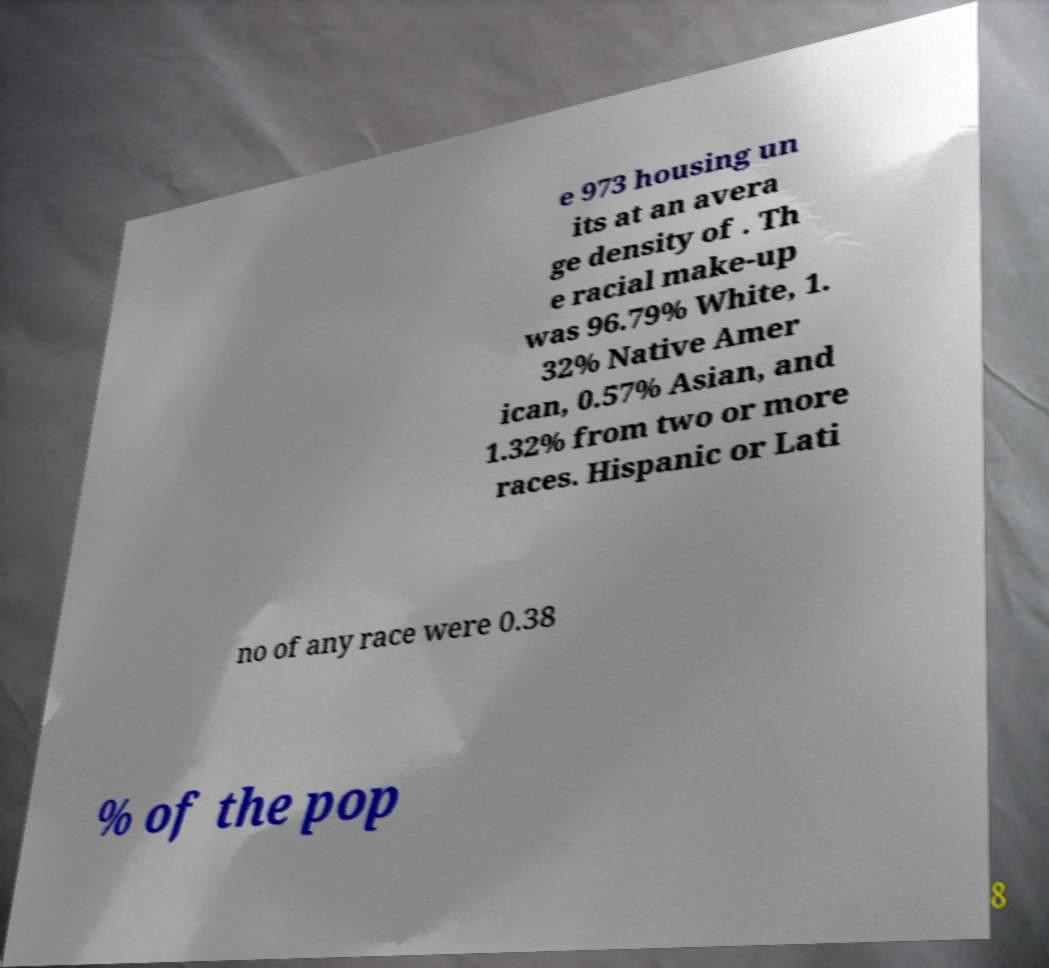There's text embedded in this image that I need extracted. Can you transcribe it verbatim? e 973 housing un its at an avera ge density of . Th e racial make-up was 96.79% White, 1. 32% Native Amer ican, 0.57% Asian, and 1.32% from two or more races. Hispanic or Lati no of any race were 0.38 % of the pop 